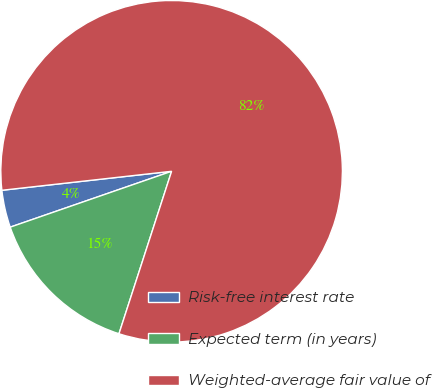Convert chart to OTSL. <chart><loc_0><loc_0><loc_500><loc_500><pie_chart><fcel>Risk-free interest rate<fcel>Expected term (in years)<fcel>Weighted-average fair value of<nl><fcel>3.53%<fcel>14.71%<fcel>81.76%<nl></chart> 